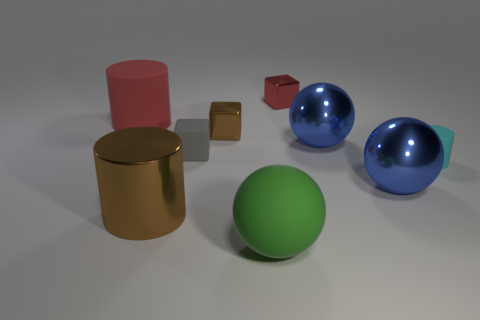What textures can be identified on the objects in the image? The objects in the image display a variety of textures: the cylinder has a metallic finish, the tiny cube looks matte, the big and small spheres seem glossy, and the cube on the left has a translucent appearance. Each texture interacts with the light differently, giving clues about the materials they represent. 